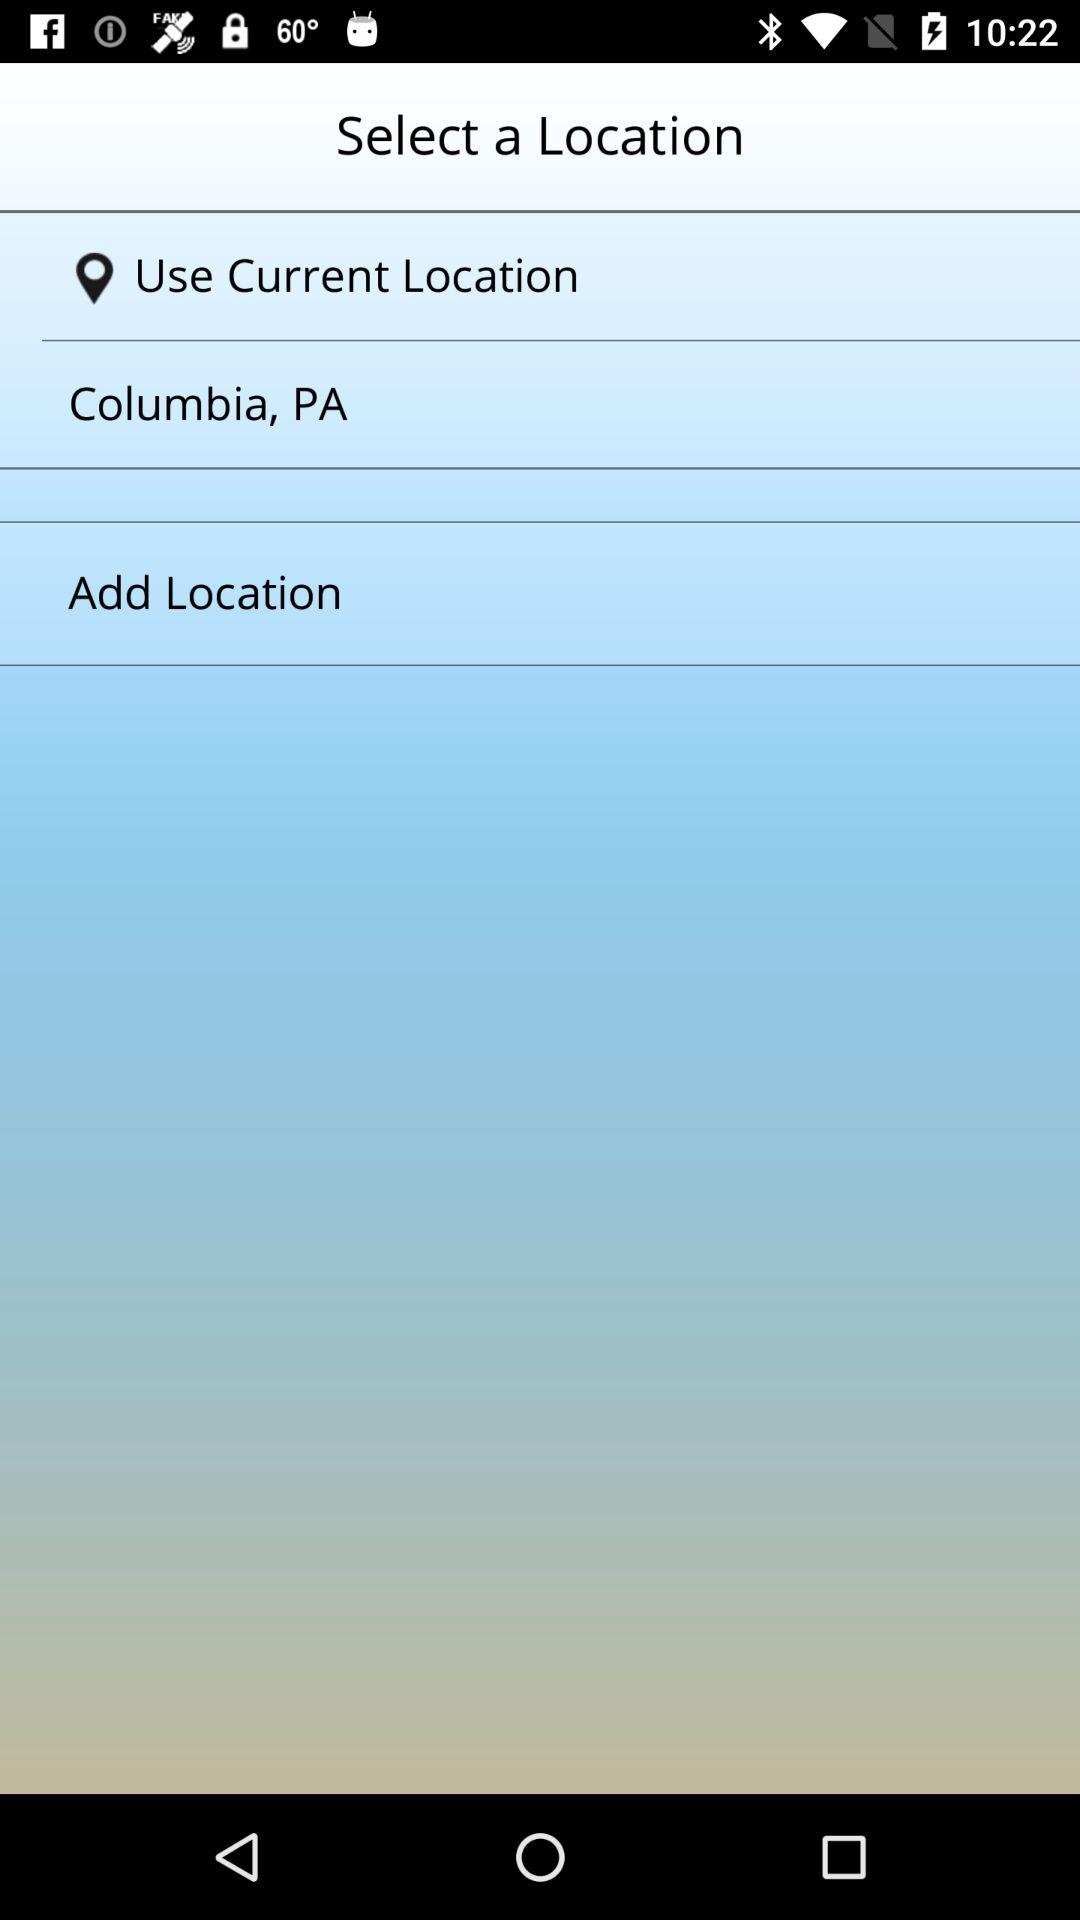How many options are there to choose a location?
Answer the question using a single word or phrase. 3 